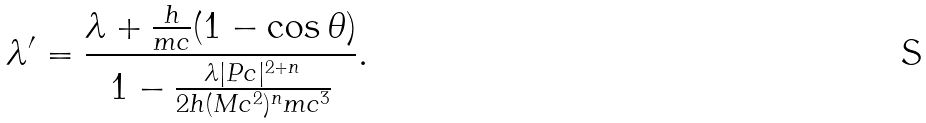<formula> <loc_0><loc_0><loc_500><loc_500>\lambda ^ { \prime } = \frac { \lambda + \frac { h } { m c } ( 1 - \cos \theta ) } { 1 - \frac { \lambda | P c | ^ { 2 + n } } { 2 h ( M c ^ { 2 } ) ^ { n } m c ^ { 3 } } } .</formula> 